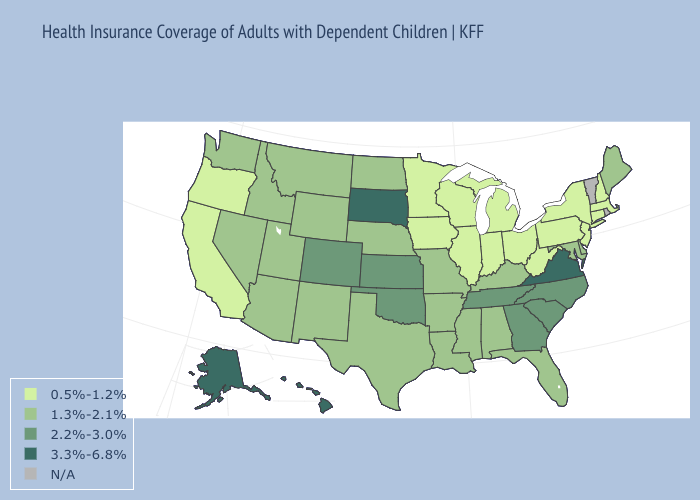Name the states that have a value in the range 2.2%-3.0%?
Give a very brief answer. Colorado, Georgia, Kansas, North Carolina, Oklahoma, South Carolina, Tennessee. Name the states that have a value in the range 0.5%-1.2%?
Write a very short answer. California, Connecticut, Illinois, Indiana, Iowa, Massachusetts, Michigan, Minnesota, New Hampshire, New Jersey, New York, Ohio, Oregon, Pennsylvania, West Virginia, Wisconsin. Name the states that have a value in the range N/A?
Give a very brief answer. Rhode Island, Vermont. Does the map have missing data?
Keep it brief. Yes. Name the states that have a value in the range 0.5%-1.2%?
Short answer required. California, Connecticut, Illinois, Indiana, Iowa, Massachusetts, Michigan, Minnesota, New Hampshire, New Jersey, New York, Ohio, Oregon, Pennsylvania, West Virginia, Wisconsin. What is the lowest value in states that border Arkansas?
Answer briefly. 1.3%-2.1%. What is the lowest value in states that border Oregon?
Give a very brief answer. 0.5%-1.2%. Among the states that border New Jersey , which have the lowest value?
Write a very short answer. New York, Pennsylvania. Name the states that have a value in the range 2.2%-3.0%?
Write a very short answer. Colorado, Georgia, Kansas, North Carolina, Oklahoma, South Carolina, Tennessee. What is the highest value in states that border Delaware?
Give a very brief answer. 1.3%-2.1%. What is the value of Nebraska?
Keep it brief. 1.3%-2.1%. Name the states that have a value in the range N/A?
Give a very brief answer. Rhode Island, Vermont. Name the states that have a value in the range 3.3%-6.8%?
Write a very short answer. Alaska, Hawaii, South Dakota, Virginia. 